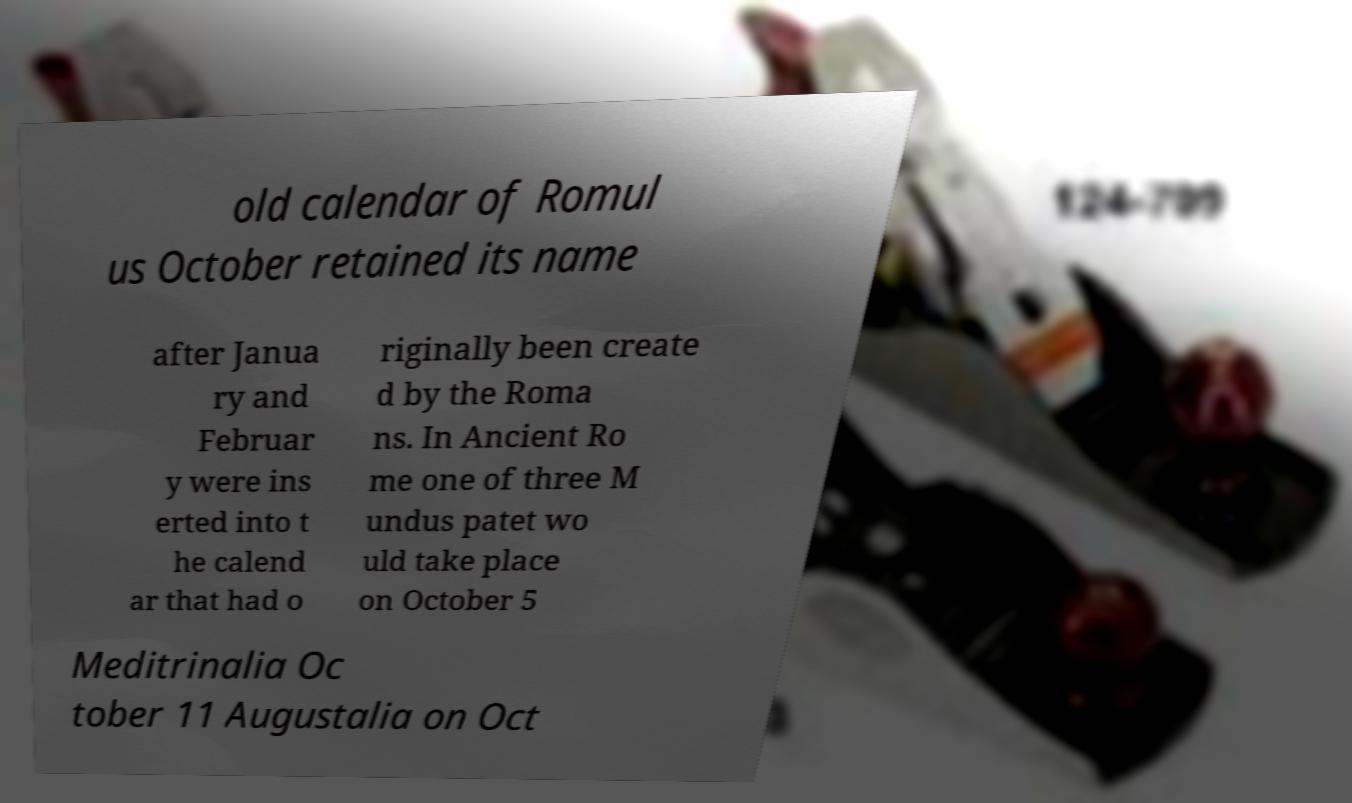There's text embedded in this image that I need extracted. Can you transcribe it verbatim? old calendar of Romul us October retained its name after Janua ry and Februar y were ins erted into t he calend ar that had o riginally been create d by the Roma ns. In Ancient Ro me one of three M undus patet wo uld take place on October 5 Meditrinalia Oc tober 11 Augustalia on Oct 